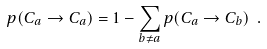<formula> <loc_0><loc_0><loc_500><loc_500>p ( C _ { a } \to C _ { a } ) = 1 - \sum _ { b \neq a } p ( C _ { a } \to C _ { b } ) \ .</formula> 